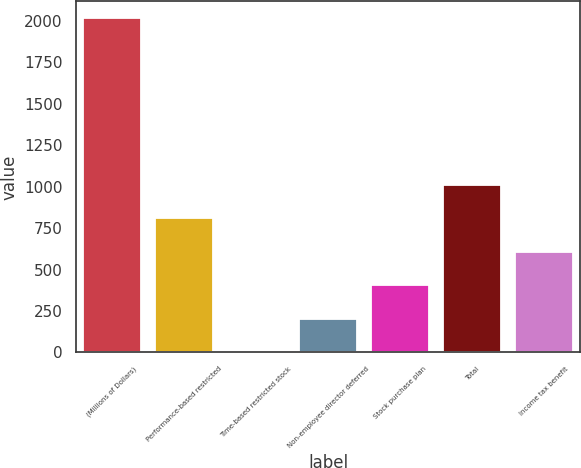Convert chart. <chart><loc_0><loc_0><loc_500><loc_500><bar_chart><fcel>(Millions of Dollars)<fcel>Performance-based restricted<fcel>Time-based restricted stock<fcel>Non-employee director deferred<fcel>Stock purchase plan<fcel>Total<fcel>Income tax benefit<nl><fcel>2017<fcel>808<fcel>2<fcel>203.5<fcel>405<fcel>1009.5<fcel>606.5<nl></chart> 